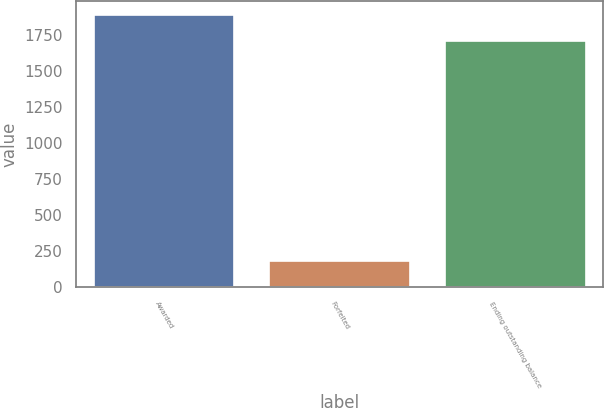<chart> <loc_0><loc_0><loc_500><loc_500><bar_chart><fcel>Awarded<fcel>Forfeited<fcel>Ending outstanding balance<nl><fcel>1891<fcel>184<fcel>1707<nl></chart> 